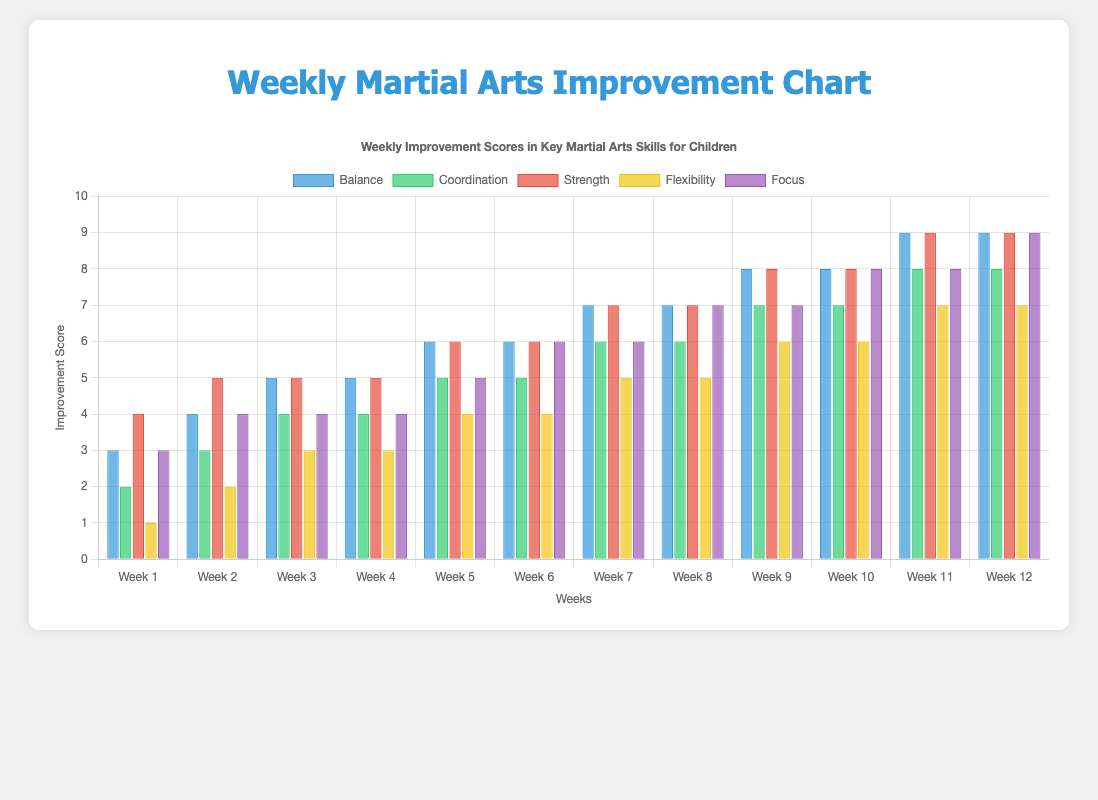What's the highest improvement score for Flexibility by the end of Week 12? To determine the highest improvement score for Flexibility by Week 12, look at the dataset and find the Flexibility score for Week 12, which is 7.
Answer: 7 Which skill showed the most improvement overall from Week 1 to Week 12? To determine the skill with the most improvement from Week 1 to Week 12, calculate the difference between the scores for Week 12 and Week 1 for each skill: Balance (9-3=6), Coordination (8-2=6), Strength (9-4=5), Flexibility (7-1=6), Focus (9-3=6). Balance, Coordination, Flexibility, and Focus all improved by 6 points.
Answer: Balance, Coordination, Flexibility, Focus Which week has the highest Focus improvement score, and what is the value? To find the week with the highest Focus improvement score, identify the maximum score under Focus which is 9, and look for the corresponding week which is Week 12.
Answer: Week 12, 9 Between Week 3 and Week 6, which skill shows the least improvement? Calculate the improvement for each skill from Week 3 to Week 6: Balance (6-5=1), Coordination (5-4=1), Strength (6-5=1), Flexibility (4-3=1), Focus (6-4=2). Flexibility, Coordination, Balance, and Strength all show the least improvement of 1 point each.
Answer: Flexibility, Coordination, Balance, Strength What is the total improvement in Strength from Week 2 to Week 10? Add the weekly increments of Strength from Week 2 to Week 10: Week 2=5, Week 10=8. Increment = (3+5-4) = 8-5 = 3, total is 8 -5 from Week 1. Sum up changes to get the total improvement.
Answer: 4 Is there a week where all skills have the same improvement score? If so, which week? Review the dataset for any weeks where Balance, Coordination, Strength, Flexibility, and Focus all have the same score. There isn't any such week.
Answer: No In which week did Focus first reach a score of 8? To find out when Focus first reached a score of 8, look through the weeks and identify when Focus equaled 8. This happens in Week 10.
Answer: Week 10 Which skill has the highest score in Week 5? Look at Week 5 and compare scores across the skills. The highest score is in Strength (6).
Answer: Strength What is the average improvement score of Coordination over all weeks? To find the average improvement score of Coordination, sum up the scores from each week (2+3+4+4+5+5+6+6+7+7+8+8=65) and divide by the number of weeks (12). The average is 65/12 = 5.42.
Answer: 5.42 